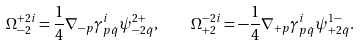Convert formula to latex. <formula><loc_0><loc_0><loc_500><loc_500>\Omega ^ { + 2 i } _ { - 2 } = \frac { 1 } { 4 } \nabla _ { - p } \gamma ^ { i } _ { p \dot { q } } \psi ^ { 2 + } _ { - 2 \dot { q } } , \quad \Omega ^ { - 2 i } _ { + 2 } = - \frac { 1 } { 4 } \nabla _ { + p } \gamma ^ { i } _ { p \dot { q } } \psi ^ { 1 - } _ { + 2 \dot { q } } .</formula> 